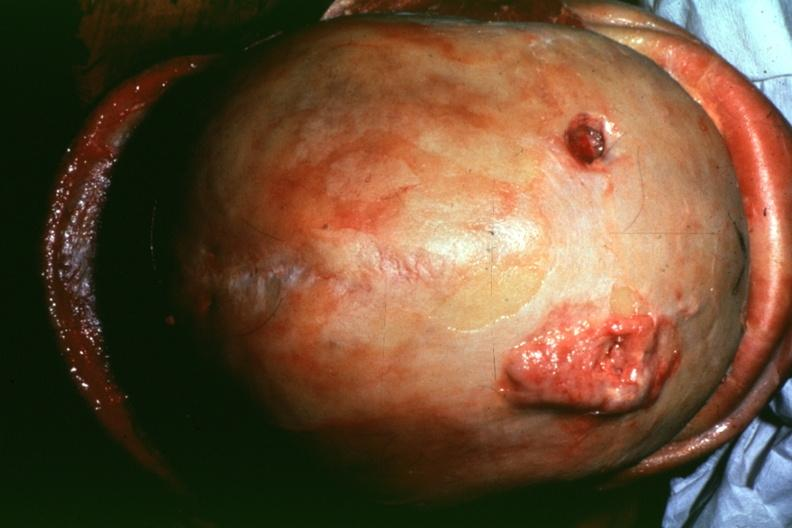s bone, calvarium present?
Answer the question using a single word or phrase. Yes 